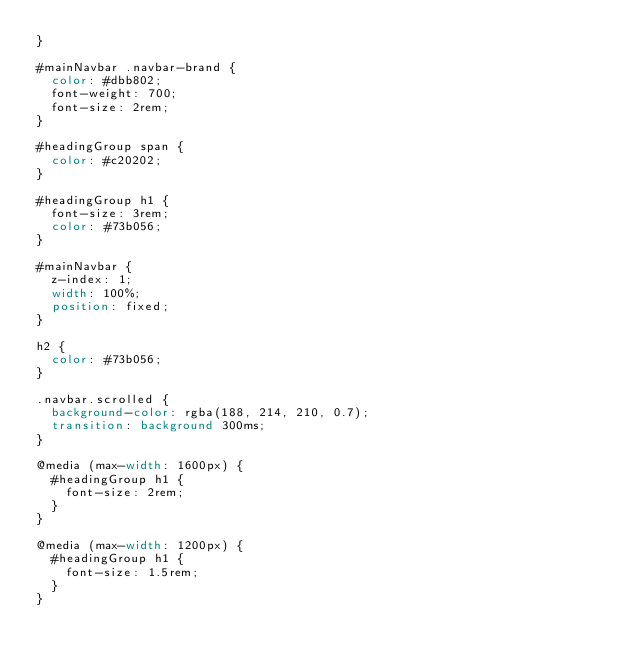<code> <loc_0><loc_0><loc_500><loc_500><_CSS_>}

#mainNavbar .navbar-brand {
  color: #dbb802;
  font-weight: 700;
  font-size: 2rem;
}

#headingGroup span {
  color: #c20202;
}

#headingGroup h1 {
  font-size: 3rem;
  color: #73b056;
}

#mainNavbar {
  z-index: 1;
  width: 100%;
  position: fixed;
}

h2 {
  color: #73b056;
}

.navbar.scrolled {
  background-color: rgba(188, 214, 210, 0.7);
  transition: background 300ms;
}

@media (max-width: 1600px) {
  #headingGroup h1 {
    font-size: 2rem;
  }
}

@media (max-width: 1200px) {
  #headingGroup h1 {
    font-size: 1.5rem;
  }
}
</code> 